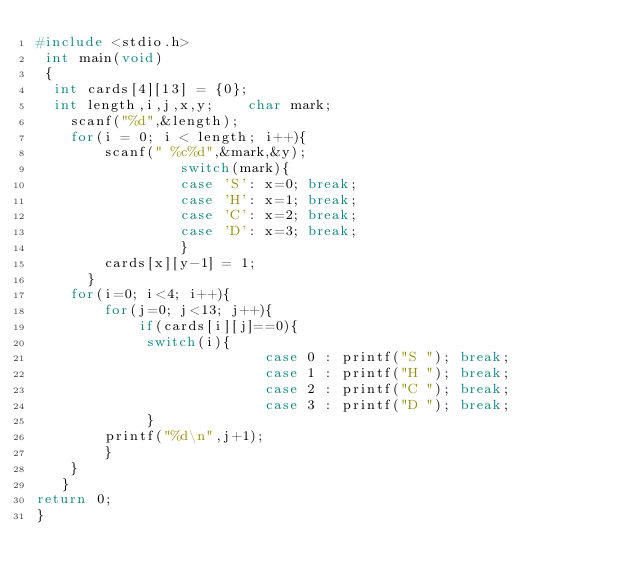Convert code to text. <code><loc_0><loc_0><loc_500><loc_500><_C_>#include <stdio.h>
 int main(void)
 {        
  int cards[4][13] = {0};    
  int length,i,j,x,y;    char mark;
    scanf("%d",&length);
    for(i = 0; i < length; i++){
        scanf(" %c%d",&mark,&y);
                 switch(mark){
                 case 'S': x=0; break;
                 case 'H': x=1; break;
                 case 'C': x=2; break;
                 case 'D': x=3; break;
                 }
        cards[x][y-1] = 1;
      }
    for(i=0; i<4; i++){
        for(j=0; j<13; j++){
            if(cards[i][j]==0){
             switch(i){
                           case 0 : printf("S "); break;
                           case 1 : printf("H "); break;
                           case 2 : printf("C "); break;
                           case 3 : printf("D "); break;
             }
        printf("%d\n",j+1);
        }
    }
   }
return 0;
}</code> 